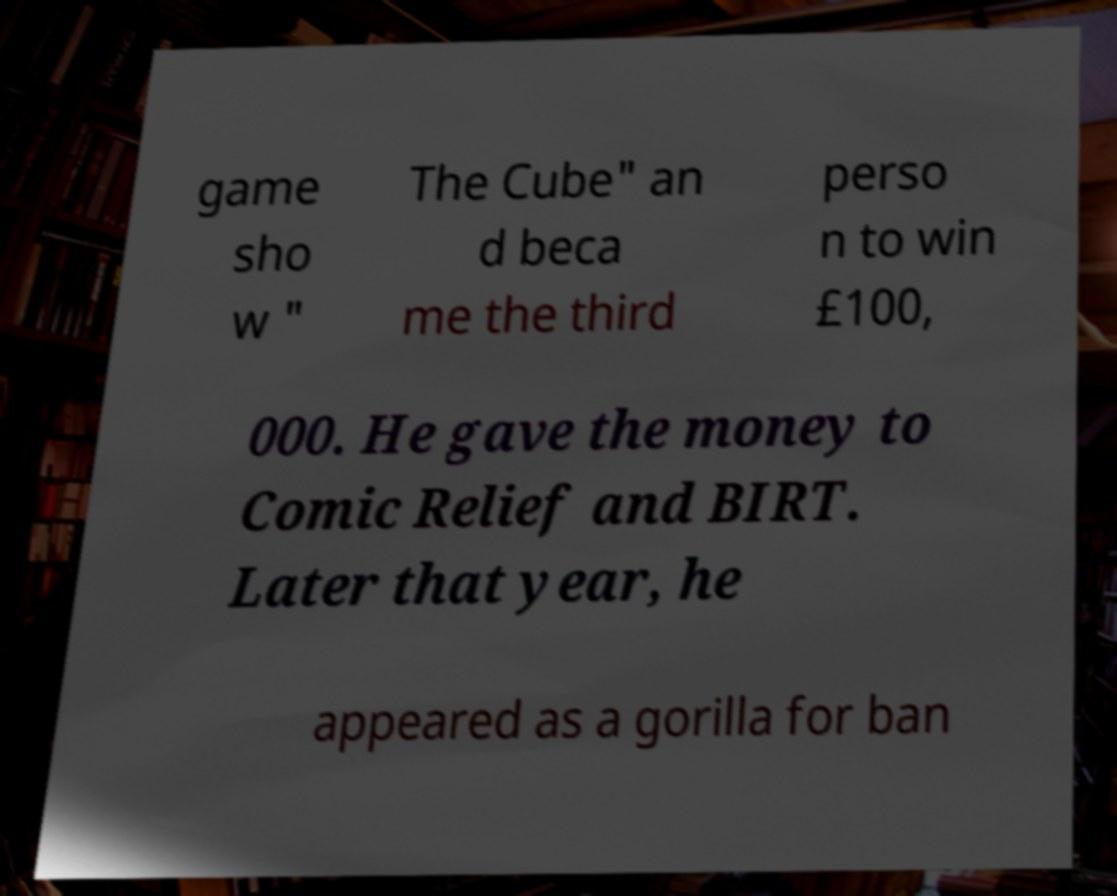Could you assist in decoding the text presented in this image and type it out clearly? game sho w " The Cube" an d beca me the third perso n to win £100, 000. He gave the money to Comic Relief and BIRT. Later that year, he appeared as a gorilla for ban 